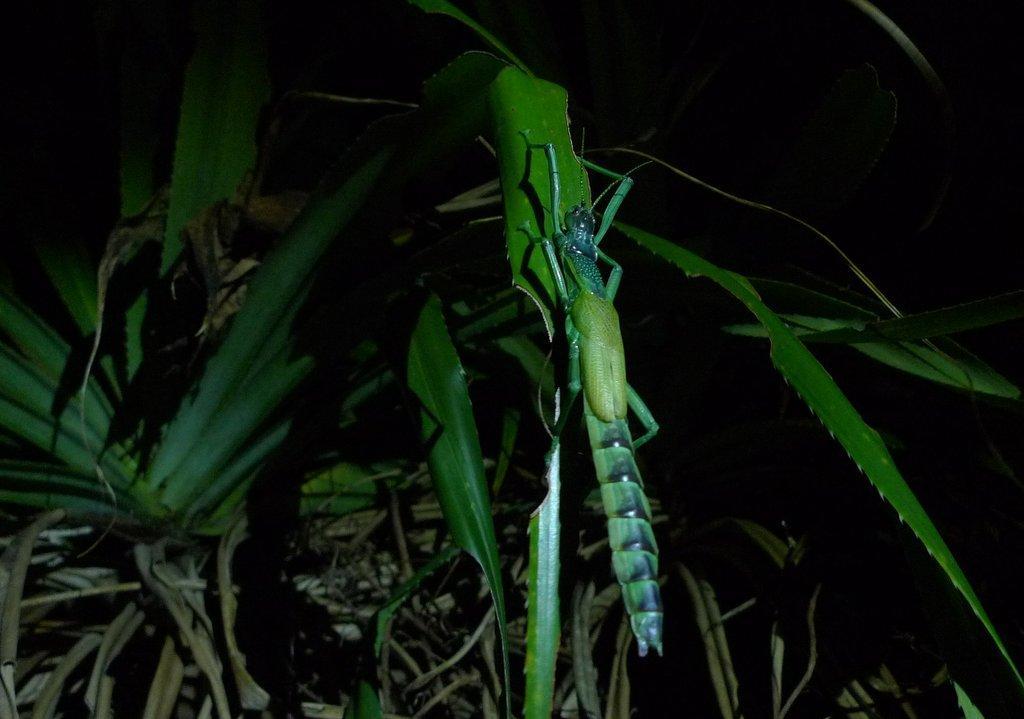Could you give a brief overview of what you see in this image? In this picture we can see an insect in the middle of the image, and we can see few plants. 